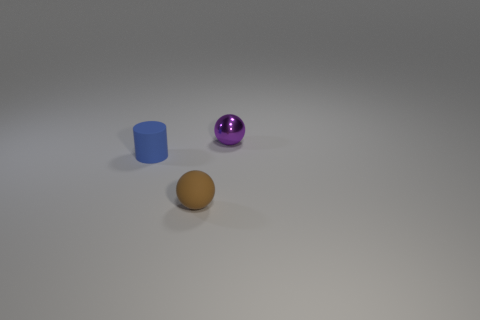There is another tiny object that is the same shape as the small brown matte thing; what color is it?
Ensure brevity in your answer.  Purple. How many small things are both right of the blue thing and behind the small brown thing?
Offer a very short reply. 1. Are there more rubber cylinders that are behind the tiny purple object than small purple metal things in front of the brown sphere?
Ensure brevity in your answer.  No. What size is the brown matte thing?
Your response must be concise. Small. Is there a brown shiny thing of the same shape as the small purple shiny thing?
Provide a short and direct response. No. Do the brown thing and the tiny object that is on the left side of the small brown ball have the same shape?
Offer a terse response. No. What size is the thing that is to the left of the tiny purple sphere and on the right side of the small blue matte cylinder?
Give a very brief answer. Small. How many big gray spheres are there?
Offer a very short reply. 0. There is a cylinder that is the same size as the matte ball; what is it made of?
Make the answer very short. Rubber. Is there another blue matte cylinder that has the same size as the matte cylinder?
Ensure brevity in your answer.  No. 